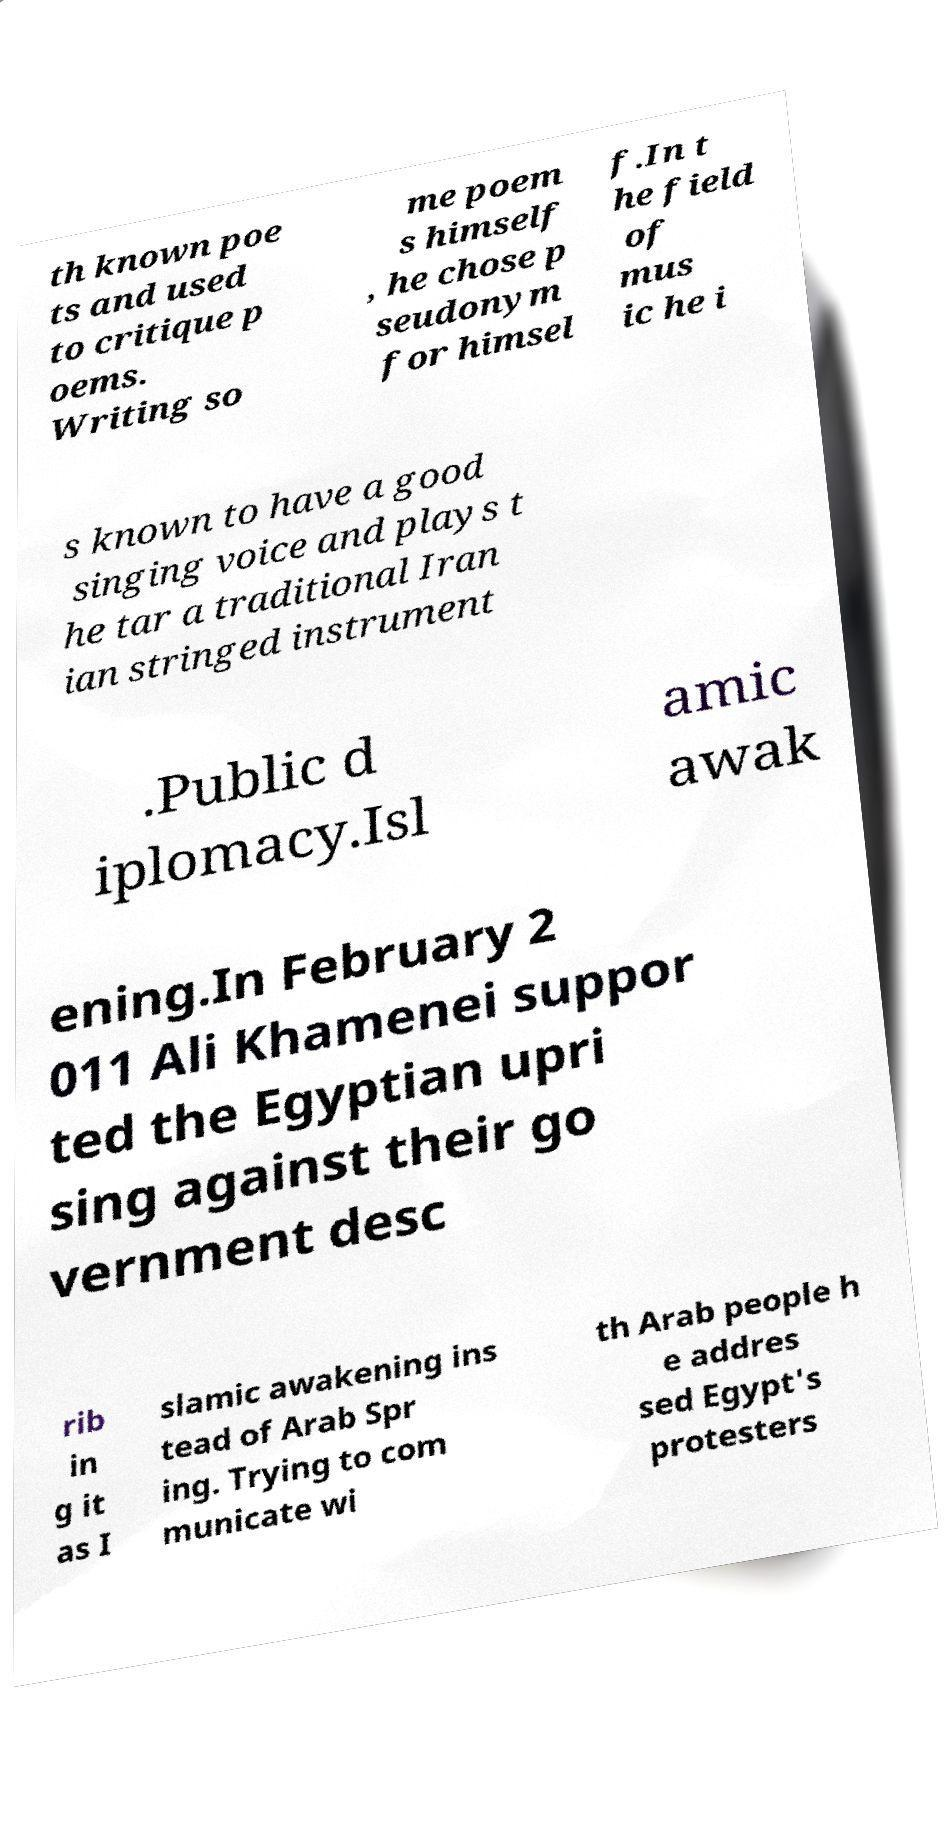For documentation purposes, I need the text within this image transcribed. Could you provide that? th known poe ts and used to critique p oems. Writing so me poem s himself , he chose p seudonym for himsel f.In t he field of mus ic he i s known to have a good singing voice and plays t he tar a traditional Iran ian stringed instrument .Public d iplomacy.Isl amic awak ening.In February 2 011 Ali Khamenei suppor ted the Egyptian upri sing against their go vernment desc rib in g it as I slamic awakening ins tead of Arab Spr ing. Trying to com municate wi th Arab people h e addres sed Egypt's protesters 